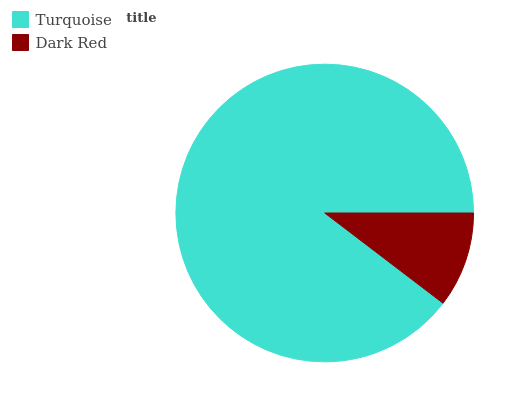Is Dark Red the minimum?
Answer yes or no. Yes. Is Turquoise the maximum?
Answer yes or no. Yes. Is Dark Red the maximum?
Answer yes or no. No. Is Turquoise greater than Dark Red?
Answer yes or no. Yes. Is Dark Red less than Turquoise?
Answer yes or no. Yes. Is Dark Red greater than Turquoise?
Answer yes or no. No. Is Turquoise less than Dark Red?
Answer yes or no. No. Is Turquoise the high median?
Answer yes or no. Yes. Is Dark Red the low median?
Answer yes or no. Yes. Is Dark Red the high median?
Answer yes or no. No. Is Turquoise the low median?
Answer yes or no. No. 